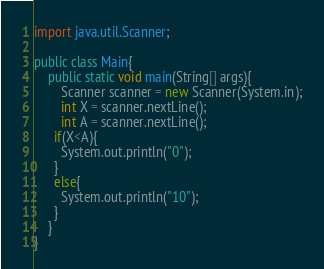<code> <loc_0><loc_0><loc_500><loc_500><_Java_>import java.util.Scanner;

public class Main{
	public static void main(String[] args){
    	Scanner scanner = new Scanner(System.in);
		int X = scanner.nextLine();
        int A = scanner.nextLine();
      if(X<A){
      	System.out.println("0");
      }
      else{
      	System.out.println("10");
      }
    }
}</code> 